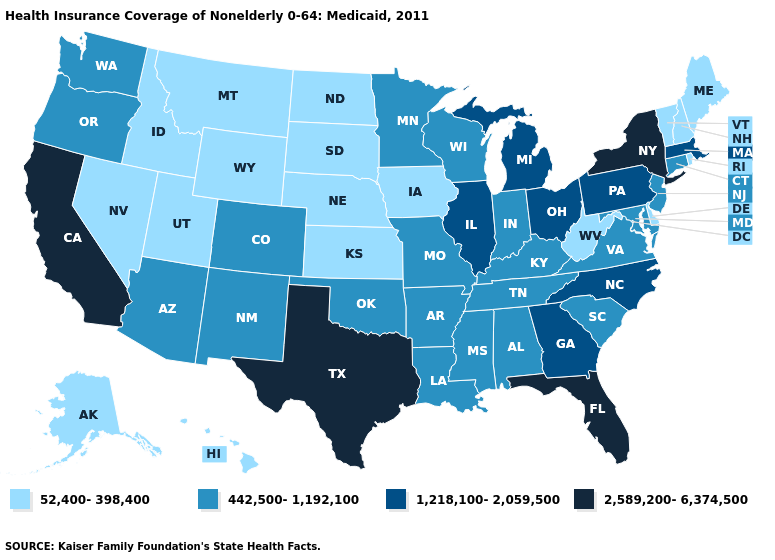Does the map have missing data?
Concise answer only. No. What is the value of New Jersey?
Quick response, please. 442,500-1,192,100. Which states have the lowest value in the West?
Answer briefly. Alaska, Hawaii, Idaho, Montana, Nevada, Utah, Wyoming. How many symbols are there in the legend?
Be succinct. 4. Name the states that have a value in the range 442,500-1,192,100?
Be succinct. Alabama, Arizona, Arkansas, Colorado, Connecticut, Indiana, Kentucky, Louisiana, Maryland, Minnesota, Mississippi, Missouri, New Jersey, New Mexico, Oklahoma, Oregon, South Carolina, Tennessee, Virginia, Washington, Wisconsin. Among the states that border Minnesota , does Wisconsin have the highest value?
Keep it brief. Yes. How many symbols are there in the legend?
Keep it brief. 4. Does Nevada have the lowest value in the West?
Keep it brief. Yes. What is the highest value in the South ?
Keep it brief. 2,589,200-6,374,500. Does Wyoming have the lowest value in the West?
Quick response, please. Yes. Does New Hampshire have the highest value in the Northeast?
Answer briefly. No. What is the value of Maryland?
Quick response, please. 442,500-1,192,100. What is the value of Alabama?
Answer briefly. 442,500-1,192,100. What is the value of Indiana?
Keep it brief. 442,500-1,192,100. What is the lowest value in the Northeast?
Keep it brief. 52,400-398,400. 